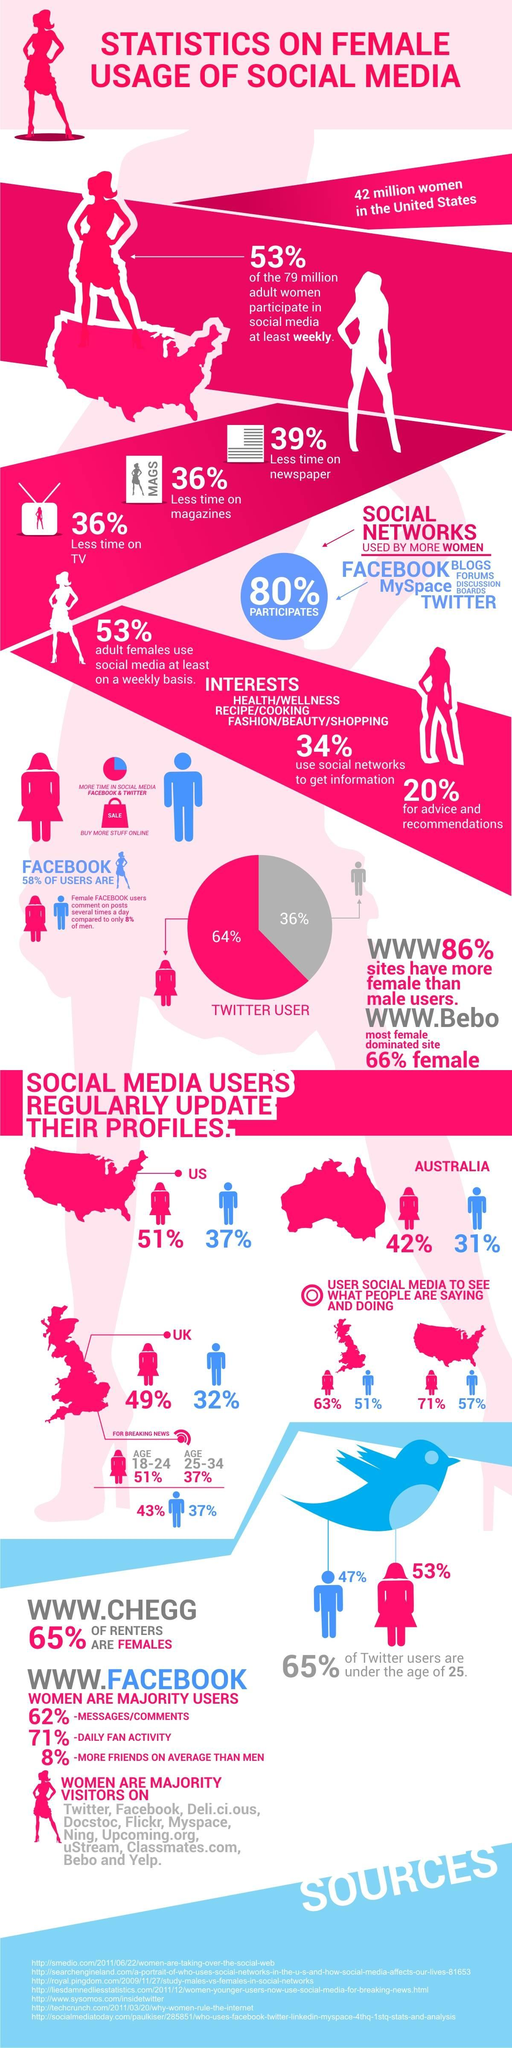List a handful of essential elements in this visual. According to a recent survey in the UK, 63% of women use social media to keep up with what others are doing. Australia has the lowest percentage of men on social media out of the three countries mentioned, which are the UK, the US, and Australia. According to a survey, 43% of women in the UK use social media to watch breaking news. 